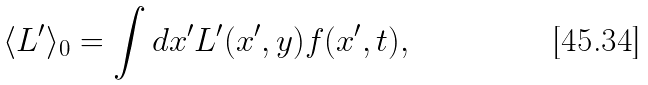<formula> <loc_0><loc_0><loc_500><loc_500>\langle L ^ { \prime } \rangle _ { 0 } = \int d x ^ { \prime } L ^ { \prime } ( x ^ { \prime } , y ) f ( x ^ { \prime } , t ) ,</formula> 